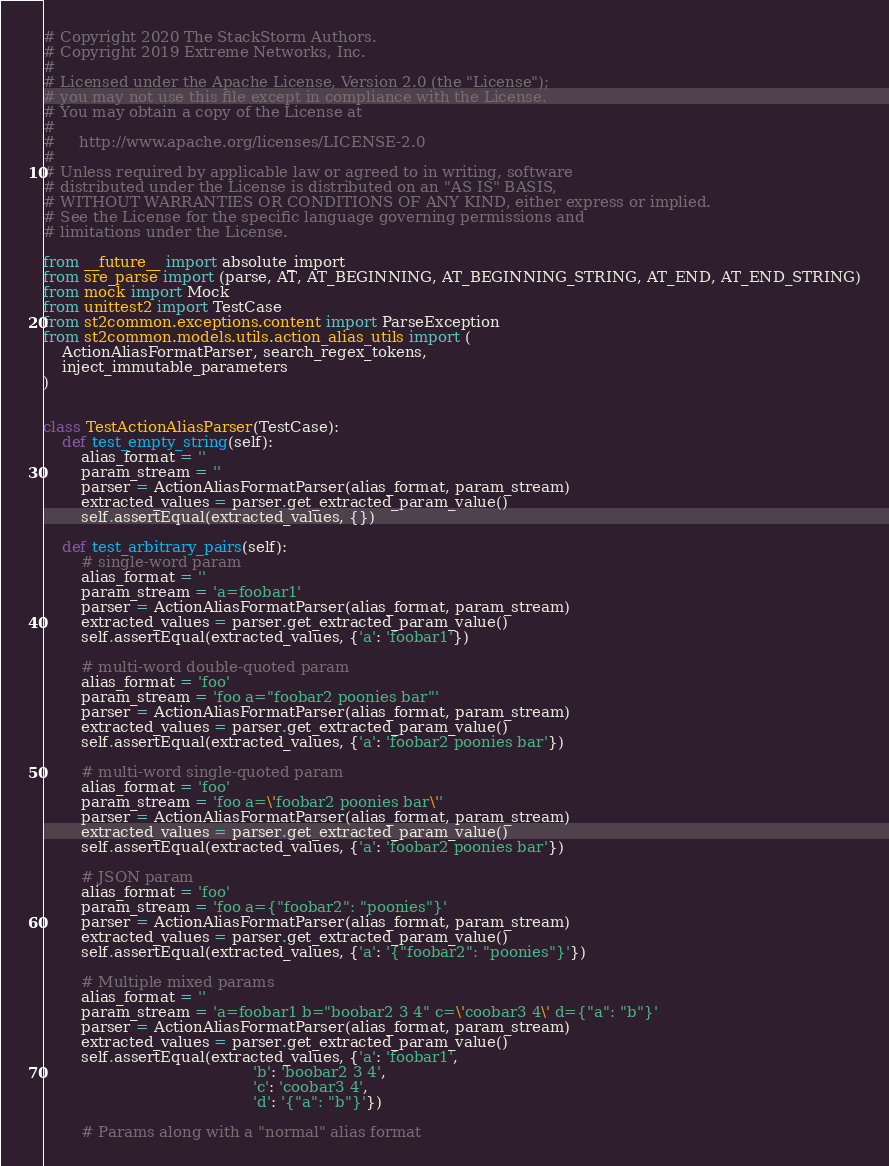Convert code to text. <code><loc_0><loc_0><loc_500><loc_500><_Python_># Copyright 2020 The StackStorm Authors.
# Copyright 2019 Extreme Networks, Inc.
#
# Licensed under the Apache License, Version 2.0 (the "License");
# you may not use this file except in compliance with the License.
# You may obtain a copy of the License at
#
#     http://www.apache.org/licenses/LICENSE-2.0
#
# Unless required by applicable law or agreed to in writing, software
# distributed under the License is distributed on an "AS IS" BASIS,
# WITHOUT WARRANTIES OR CONDITIONS OF ANY KIND, either express or implied.
# See the License for the specific language governing permissions and
# limitations under the License.

from __future__ import absolute_import
from sre_parse import (parse, AT, AT_BEGINNING, AT_BEGINNING_STRING, AT_END, AT_END_STRING)
from mock import Mock
from unittest2 import TestCase
from st2common.exceptions.content import ParseException
from st2common.models.utils.action_alias_utils import (
    ActionAliasFormatParser, search_regex_tokens,
    inject_immutable_parameters
)


class TestActionAliasParser(TestCase):
    def test_empty_string(self):
        alias_format = ''
        param_stream = ''
        parser = ActionAliasFormatParser(alias_format, param_stream)
        extracted_values = parser.get_extracted_param_value()
        self.assertEqual(extracted_values, {})

    def test_arbitrary_pairs(self):
        # single-word param
        alias_format = ''
        param_stream = 'a=foobar1'
        parser = ActionAliasFormatParser(alias_format, param_stream)
        extracted_values = parser.get_extracted_param_value()
        self.assertEqual(extracted_values, {'a': 'foobar1'})

        # multi-word double-quoted param
        alias_format = 'foo'
        param_stream = 'foo a="foobar2 poonies bar"'
        parser = ActionAliasFormatParser(alias_format, param_stream)
        extracted_values = parser.get_extracted_param_value()
        self.assertEqual(extracted_values, {'a': 'foobar2 poonies bar'})

        # multi-word single-quoted param
        alias_format = 'foo'
        param_stream = 'foo a=\'foobar2 poonies bar\''
        parser = ActionAliasFormatParser(alias_format, param_stream)
        extracted_values = parser.get_extracted_param_value()
        self.assertEqual(extracted_values, {'a': 'foobar2 poonies bar'})

        # JSON param
        alias_format = 'foo'
        param_stream = 'foo a={"foobar2": "poonies"}'
        parser = ActionAliasFormatParser(alias_format, param_stream)
        extracted_values = parser.get_extracted_param_value()
        self.assertEqual(extracted_values, {'a': '{"foobar2": "poonies"}'})

        # Multiple mixed params
        alias_format = ''
        param_stream = 'a=foobar1 b="boobar2 3 4" c=\'coobar3 4\' d={"a": "b"}'
        parser = ActionAliasFormatParser(alias_format, param_stream)
        extracted_values = parser.get_extracted_param_value()
        self.assertEqual(extracted_values, {'a': 'foobar1',
                                            'b': 'boobar2 3 4',
                                            'c': 'coobar3 4',
                                            'd': '{"a": "b"}'})

        # Params along with a "normal" alias format</code> 